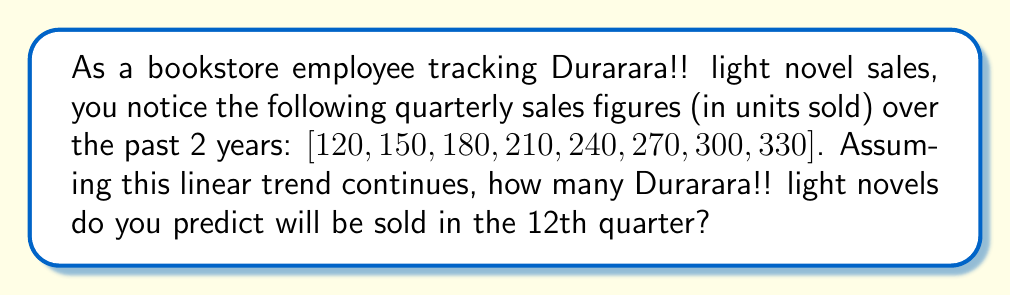Show me your answer to this math problem. Let's approach this step-by-step:

1) First, we need to identify the pattern in the given data. We can see that the sales are increasing linearly.

2) To find the linear trend, we need to calculate the constant increase between each quarter:

   $150 - 120 = 30$
   $180 - 150 = 30$
   $210 - 180 = 30$
   ...and so on.

3) We can express this sequence mathematically as an arithmetic sequence:

   $a_n = a_1 + (n-1)d$

   Where:
   $a_n$ is the nth term
   $a_1$ is the first term (120)
   $n$ is the position of the term
   $d$ is the common difference (30)

4) We want to find the 12th term, so $n = 12$:

   $a_{12} = 120 + (12-1)30$

5) Simplify:

   $a_{12} = 120 + (11)(30)$
   $a_{12} = 120 + 330$
   $a_{12} = 450$

Therefore, if the linear trend continues, we predict that 450 Durarara!! light novels will be sold in the 12th quarter.
Answer: 450 units 